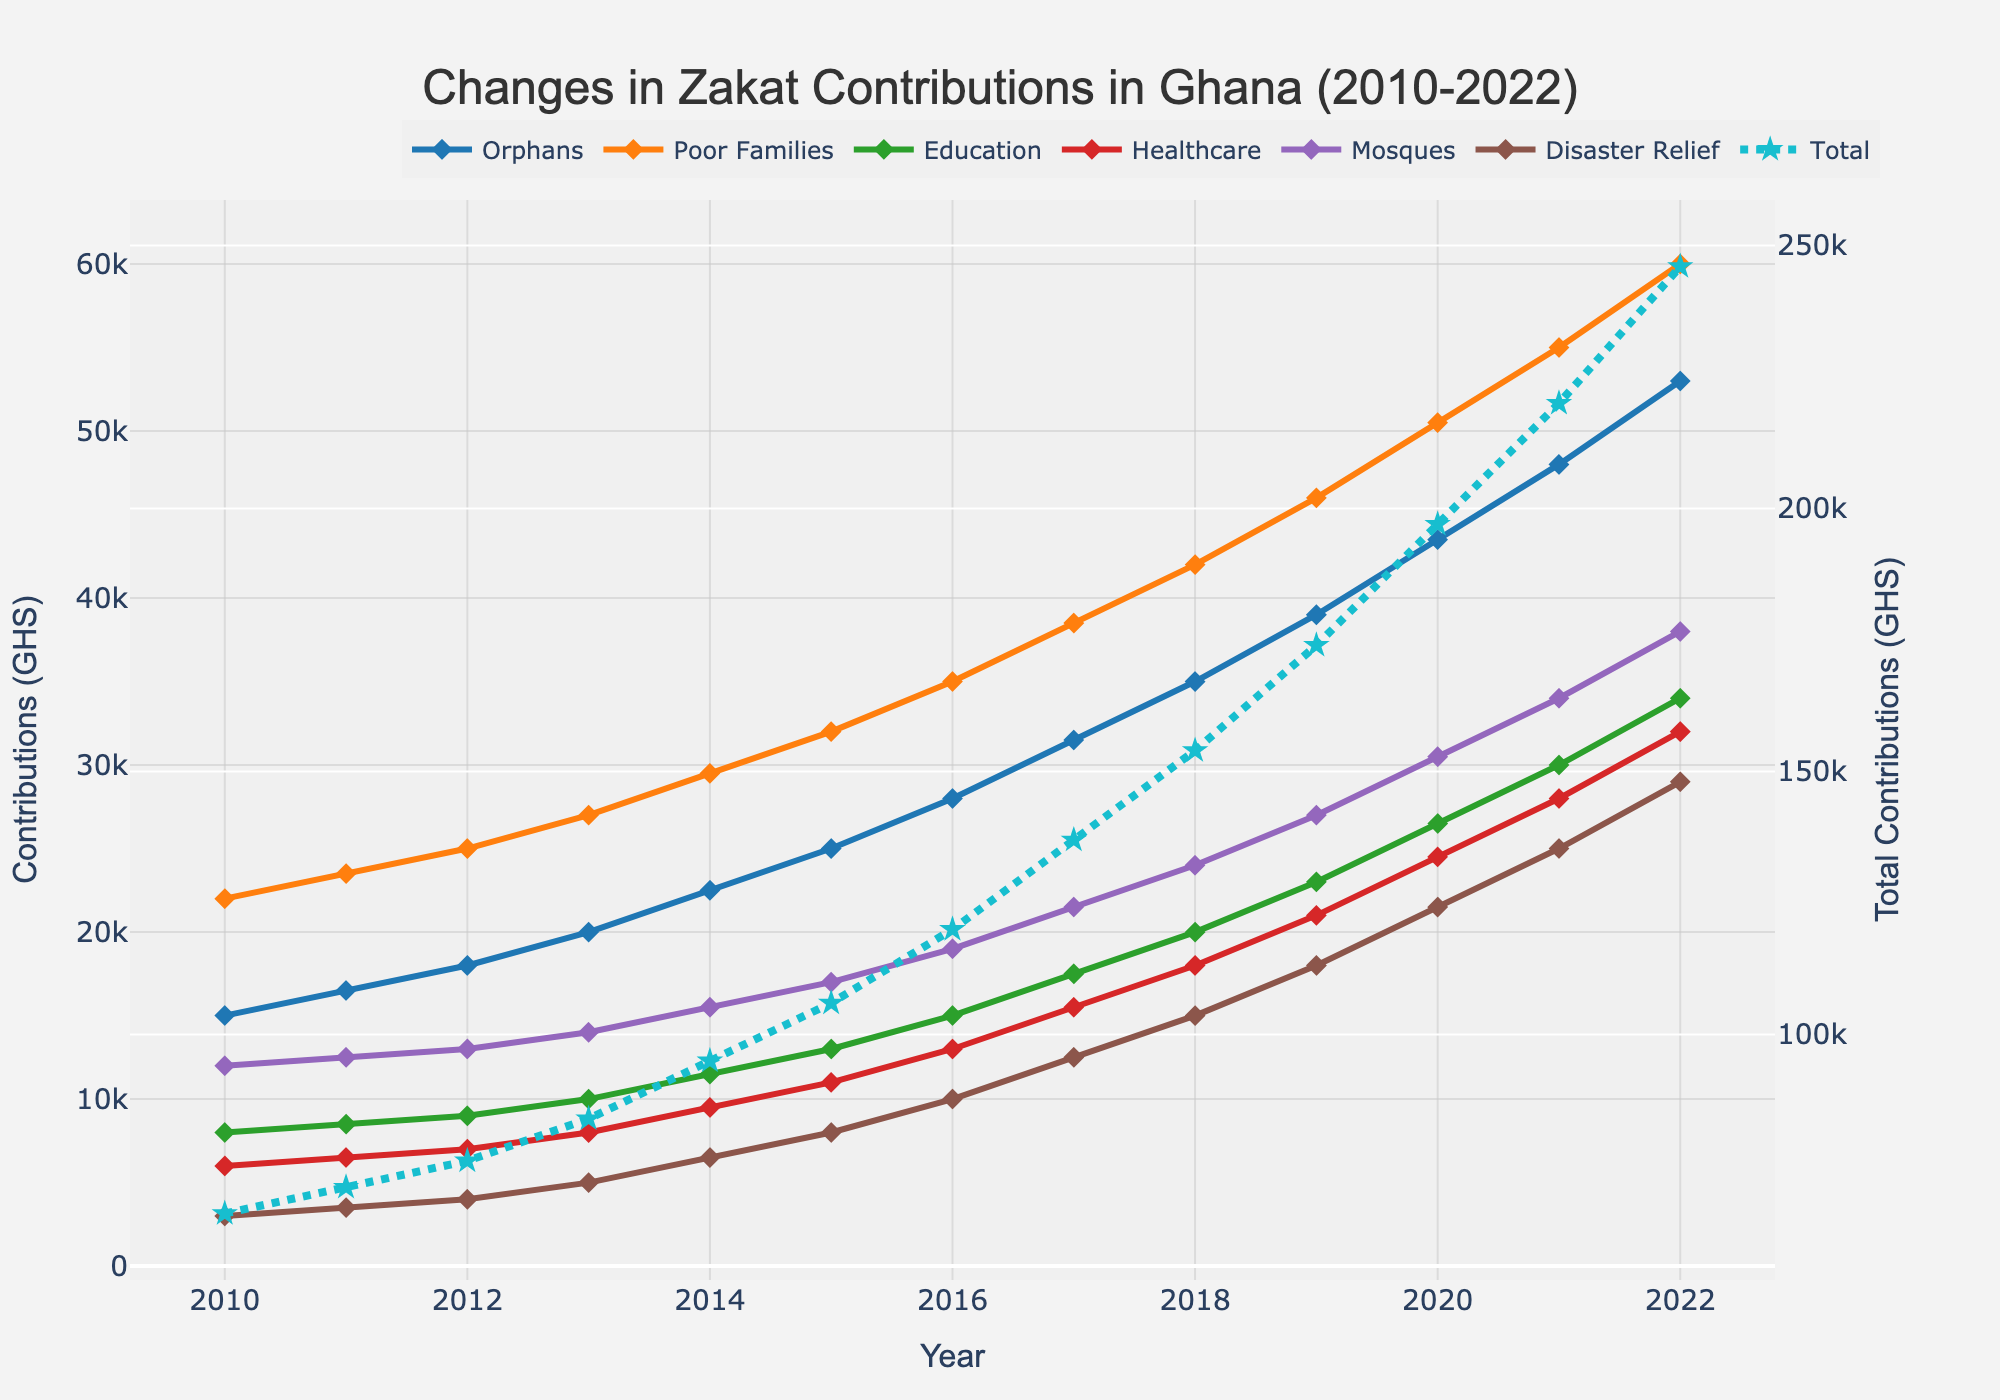What is the total zakat contribution in 2022? To find the total zakat contribution in 2022, refer to the 'Total' series in the chart. The 'Total' series is represented by a line with a different color and marked with stars. Locate the value for the year 2022 on this line.
Answer: 286000 Which type of beneficiaries saw the highest increase in zakat contributions from 2010 to 2022? To determine this, compare the contributions for each type of beneficiary in 2010 and 2022. The difference can be calculated for each type, and the highest difference indicates the largest increase.
Answer: Poor Families How did the contribution towards healthcare change between 2015 and 2020? On the chart, find the points for healthcare contributions for the years 2015 and 2020. The values are 11000 for 2015 and 24500 for 2020. Subtract the 2015 value from the 2020 value to find the change.
Answer: Increased by 13500 Which year experienced the most significant increase in total zakat contributions compared to the previous year? Examine the 'Total' line on the chart and identify the year-to-year changes. The year with the most considerable increase can be pinpointed as the one where the line shows the steepest upward slope.
Answer: 2015 How did the contribution to education change from 2010 to 2022, in terms of percentage increase? First, find the education contributions for 2010 and 2022, which are 8000 and 34000, respectively. Calculate the percentage increase using the formula: ((34000 - 8000) / 8000) * 100.
Answer: 325% Which beneficiary category received the least amount of zakat in 2020? Look at the contributions for each beneficiary type in 2020. The category with the smallest value is the one receiving the least amount of zakat.
Answer: Disaster Relief Compare the contributions towards orphans and mosques in 2015. Which received more and by how much? Locate the contributions for orphans and mosques in 2015, which are 25000 and 17000, respectively. Subtract the contribution towards mosques from that towards orphans to find the difference.
Answer: Orphans by 8000 What trend can be observed in the contributions towards disaster relief from 2010 to 2022? Observe the disaster relief series on the chart from 2010 to 2022. Notice that it steadily increases every year without any decline.
Answer: Steady Increase In which year did the contribution for orphans first exceed 30,000 GHS? Observe the series for orphans and locate the point where it first crosses the 30,000 GHS mark. This occurs between 2016 and 2017. Look at the exact year label for the first instance.
Answer: 2017 